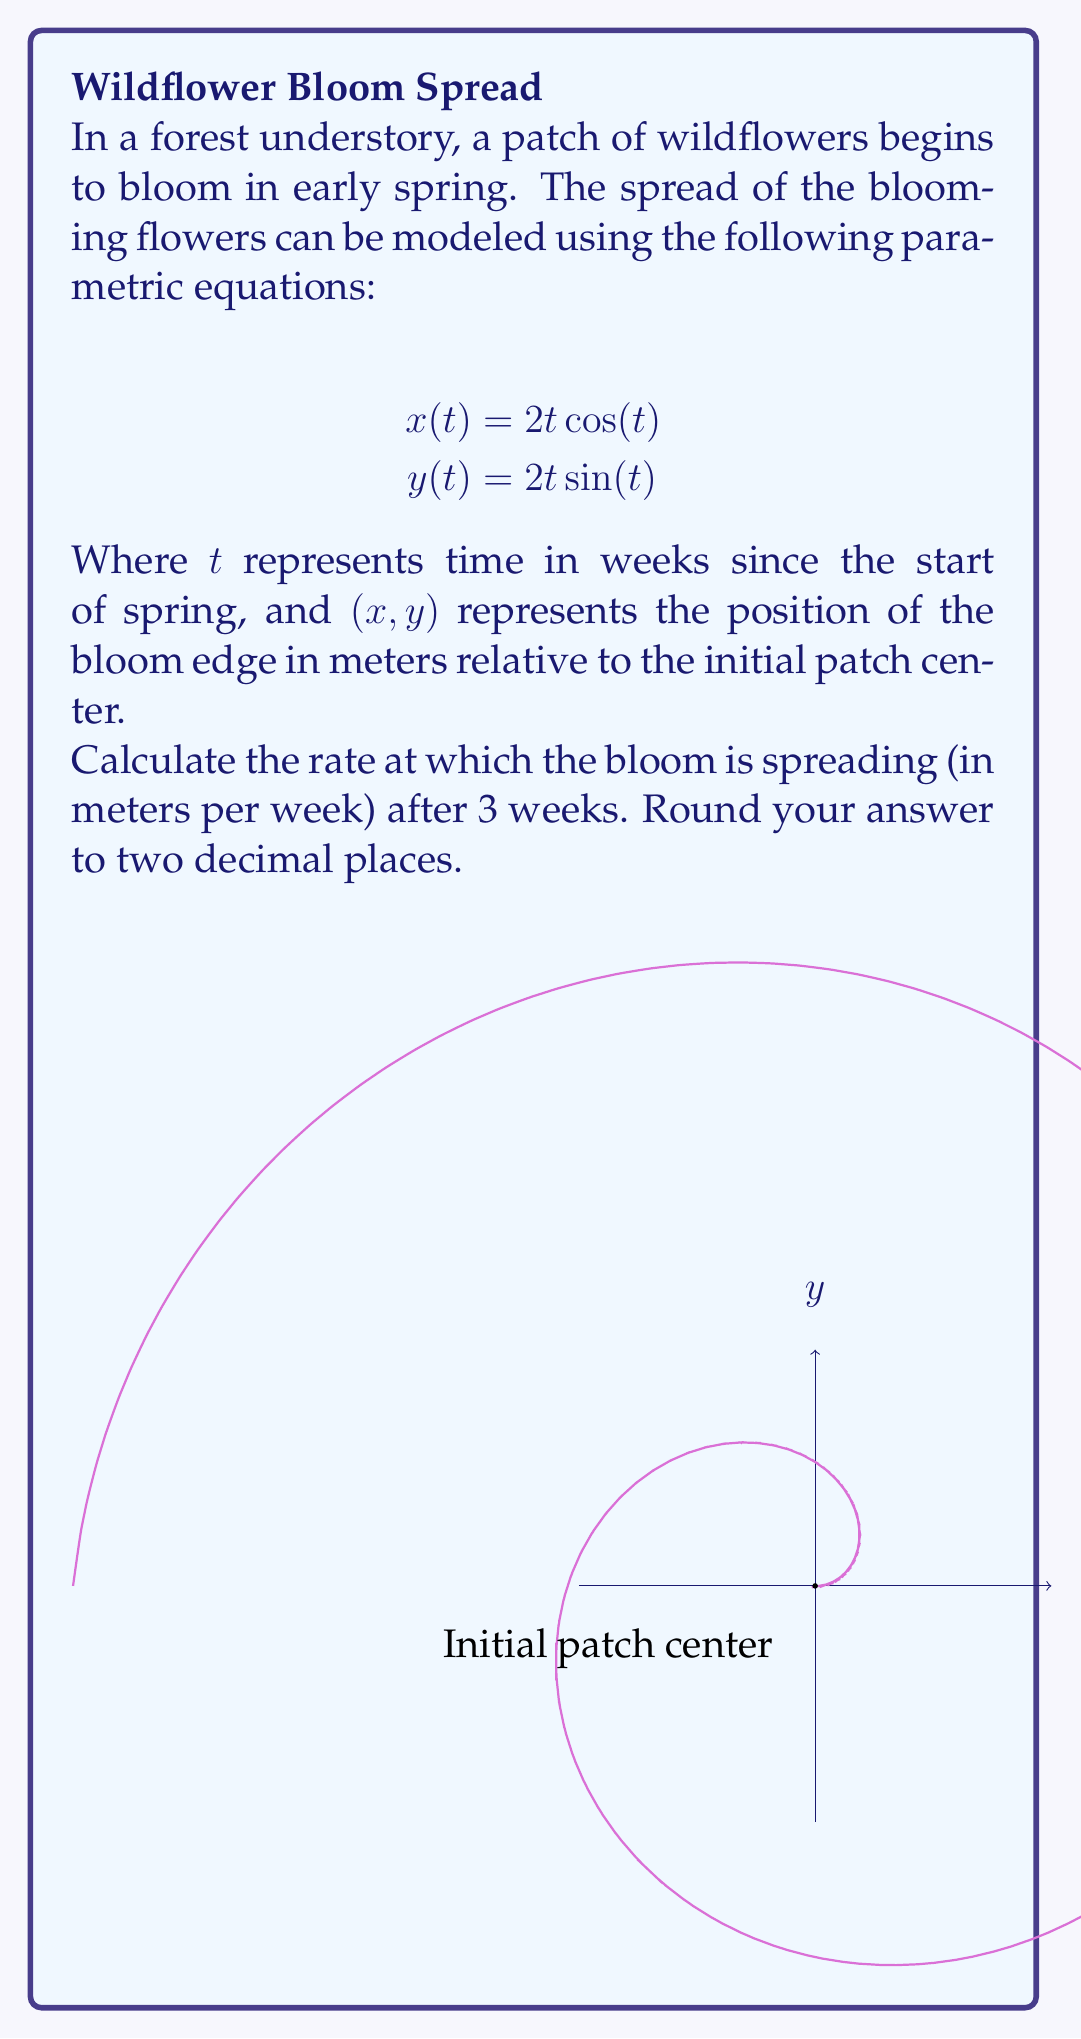Show me your answer to this math problem. To solve this problem, we need to follow these steps:

1) The rate of spread is the magnitude of the velocity vector at t = 3 weeks. We can find this using the parametric equations.

2) First, we need to find the velocity components:
   $$\frac{dx}{dt} = 2\cos(t) - 2t\sin(t)$$
   $$\frac{dy}{dt} = 2\sin(t) + 2t\cos(t)$$

3) The magnitude of the velocity vector is given by:
   $$v(t) = \sqrt{\left(\frac{dx}{dt}\right)^2 + \left(\frac{dy}{dt}\right)^2}$$

4) Substituting our expressions:
   $$v(t) = \sqrt{(2\cos(t) - 2t\sin(t))^2 + (2\sin(t) + 2t\cos(t))^2}$$

5) Simplifying:
   $$v(t) = \sqrt{4\cos^2(t) - 8t\cos(t)\sin(t) + 4t^2\sin^2(t) + 4\sin^2(t) + 8t\sin(t)\cos(t) + 4t^2\cos^2(t)}$$
   $$v(t) = \sqrt{4(\cos^2(t) + \sin^2(t)) + 4t^2(\sin^2(t) + \cos^2(t))}$$
   $$v(t) = \sqrt{4 + 4t^2} = 2\sqrt{1 + t^2}$$

6) Now we can evaluate this at t = 3:
   $$v(3) = 2\sqrt{1 + 3^2} = 2\sqrt{10} \approx 6.32$$

Therefore, after 3 weeks, the bloom is spreading at a rate of approximately 6.32 meters per week.
Answer: 6.32 m/week 